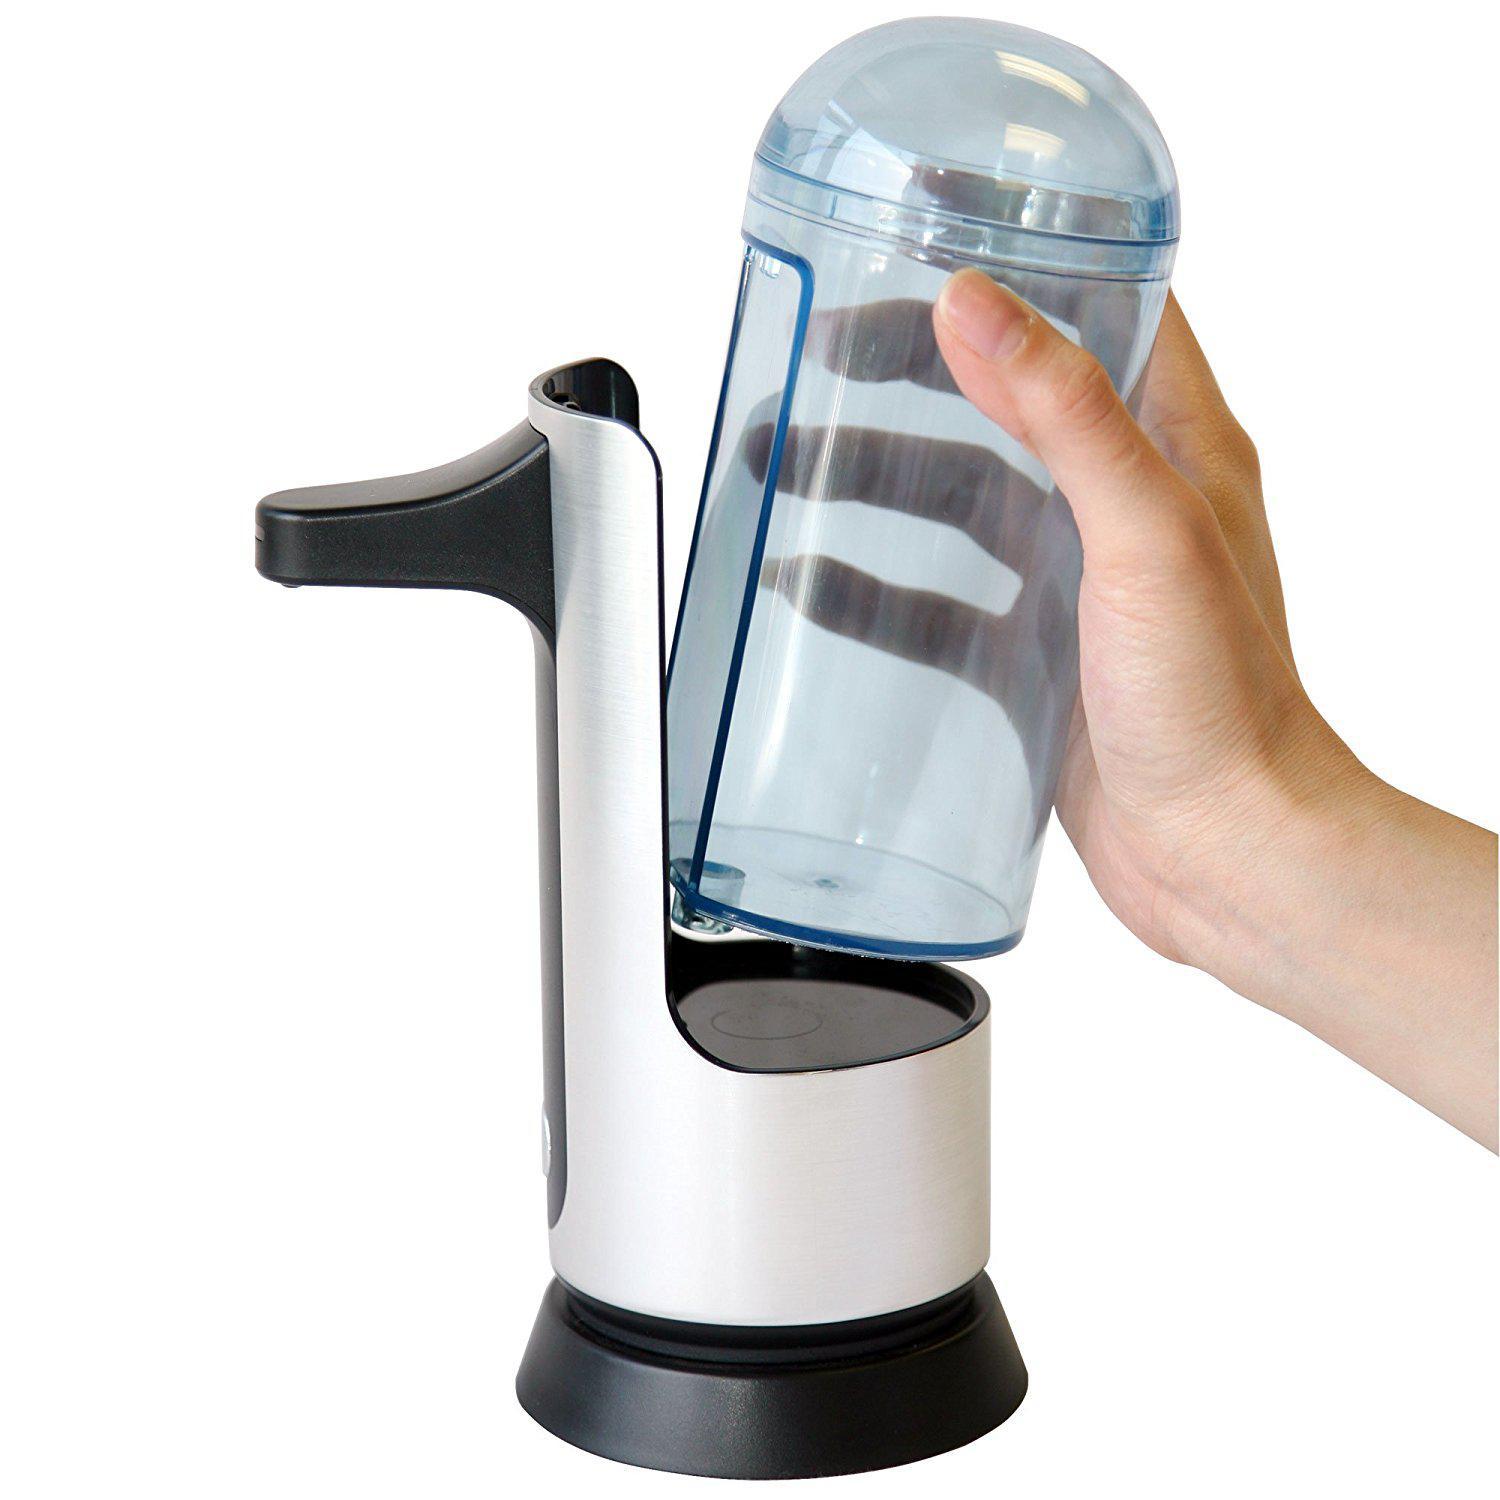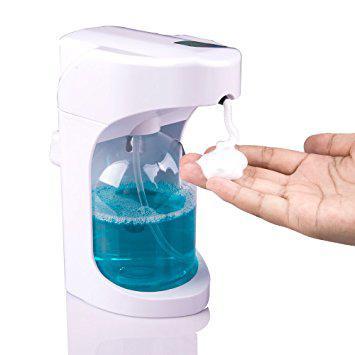The first image is the image on the left, the second image is the image on the right. Analyze the images presented: Is the assertion "The image on the right contains a human hand." valid? Answer yes or no. Yes. 